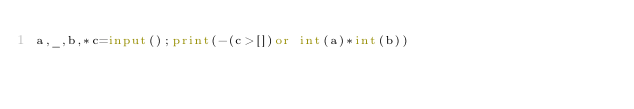Convert code to text. <code><loc_0><loc_0><loc_500><loc_500><_Python_>a,_,b,*c=input();print(-(c>[])or int(a)*int(b))</code> 